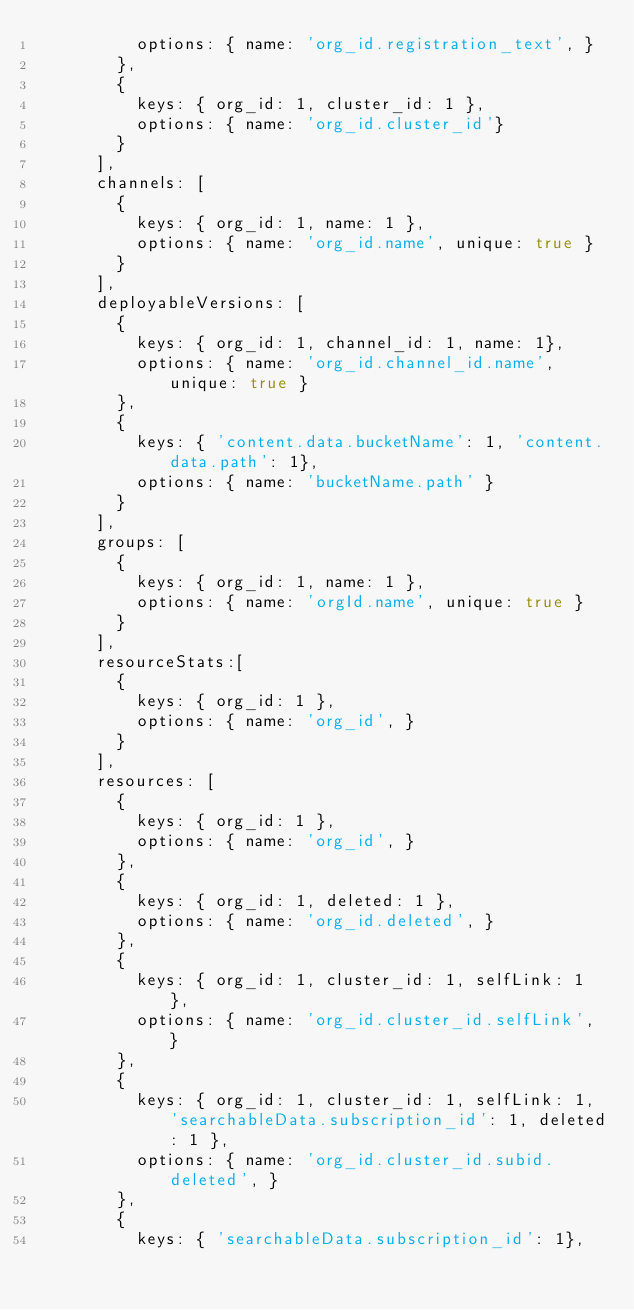<code> <loc_0><loc_0><loc_500><loc_500><_JavaScript_>          options: { name: 'org_id.registration_text', }
        },
        {
          keys: { org_id: 1, cluster_id: 1 },
          options: { name: 'org_id.cluster_id'}
        }
      ],
      channels: [
        {
          keys: { org_id: 1, name: 1 },
          options: { name: 'org_id.name', unique: true }
        }
      ],
      deployableVersions: [
        {
          keys: { org_id: 1, channel_id: 1, name: 1},
          options: { name: 'org_id.channel_id.name', unique: true }
        },
        {
          keys: { 'content.data.bucketName': 1, 'content.data.path': 1},
          options: { name: 'bucketName.path' }
        }
      ],
      groups: [
        {
          keys: { org_id: 1, name: 1 },
          options: { name: 'orgId.name', unique: true }
        }
      ],
      resourceStats:[
        {
          keys: { org_id: 1 },
          options: { name: 'org_id', }
        }
      ],
      resources: [
        {
          keys: { org_id: 1 },
          options: { name: 'org_id', }
        },
        {
          keys: { org_id: 1, deleted: 1 },
          options: { name: 'org_id.deleted', }
        },
        {
          keys: { org_id: 1, cluster_id: 1, selfLink: 1 },
          options: { name: 'org_id.cluster_id.selfLink', }
        },
        {
          keys: { org_id: 1, cluster_id: 1, selfLink: 1, 'searchableData.subscription_id': 1, deleted: 1 },
          options: { name: 'org_id.cluster_id.subid.deleted', }
        },
        {
          keys: { 'searchableData.subscription_id': 1},</code> 